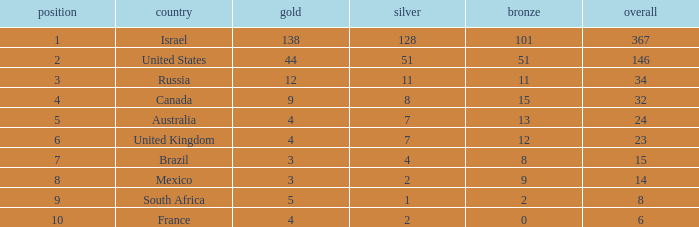What is the maximum number of silvers for a country with fewer than 12 golds and a total less than 8? 2.0. 